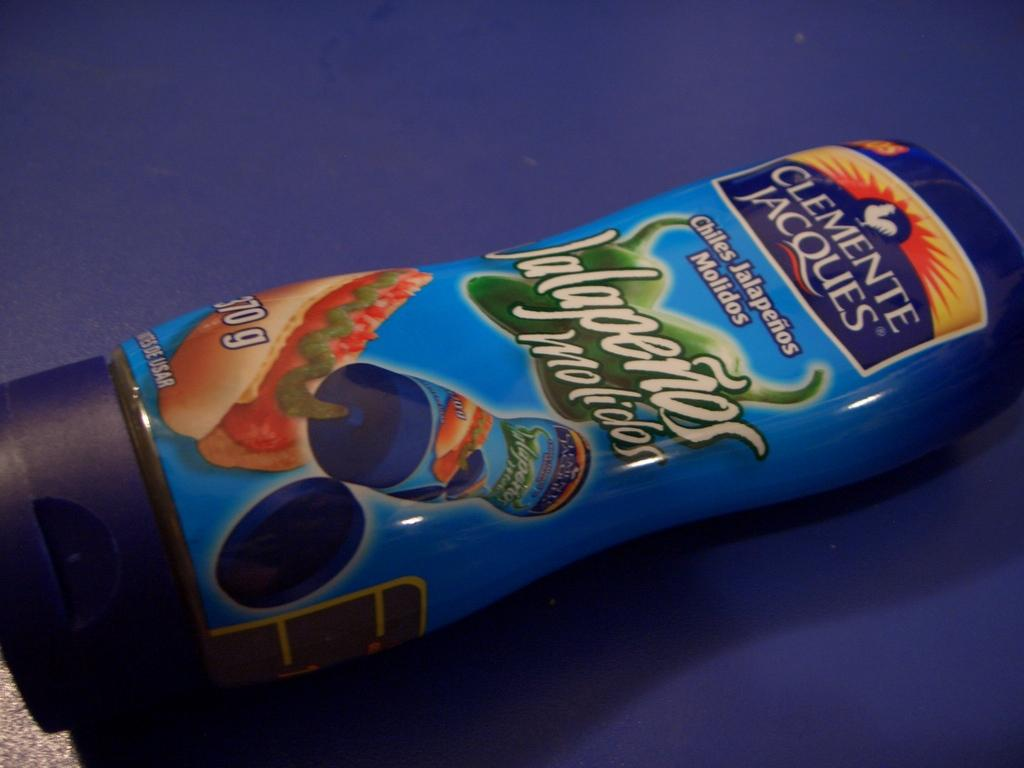<image>
Summarize the visual content of the image. A food product that is from the brand Clemente Jacques. 